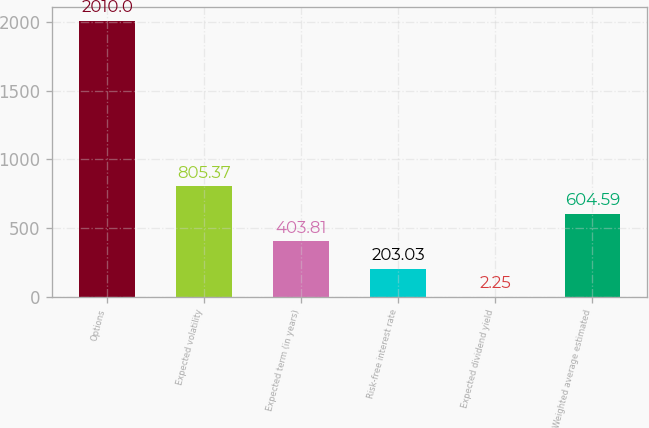<chart> <loc_0><loc_0><loc_500><loc_500><bar_chart><fcel>Options<fcel>Expected volatility<fcel>Expected term (in years)<fcel>Risk-free interest rate<fcel>Expected dividend yield<fcel>Weighted average estimated<nl><fcel>2010<fcel>805.37<fcel>403.81<fcel>203.03<fcel>2.25<fcel>604.59<nl></chart> 